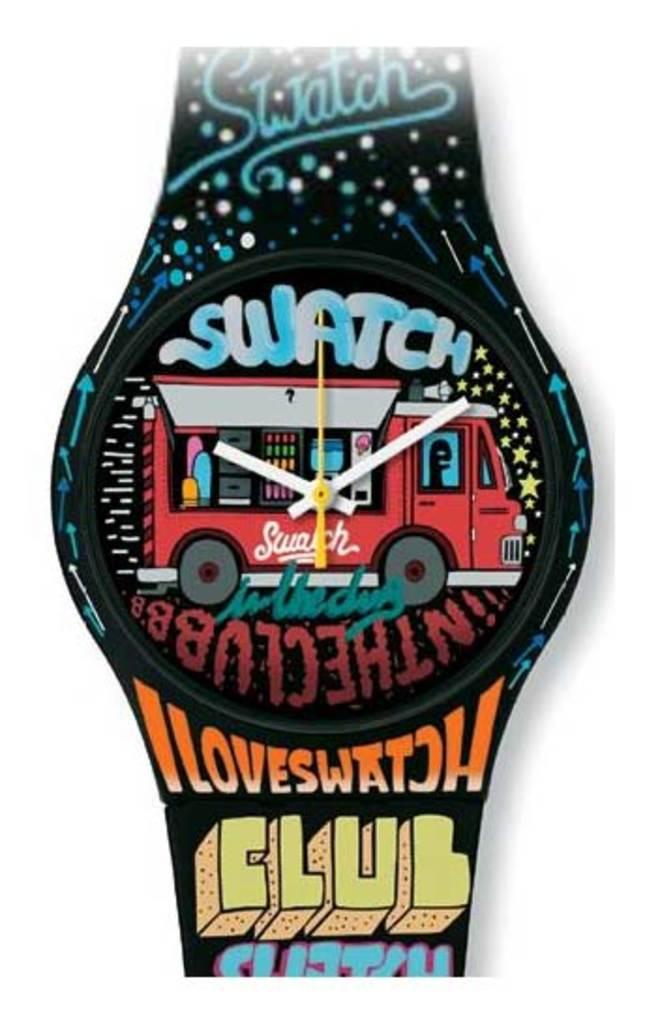What brand of watch is this?
Provide a short and direct response. Swatch. What time is it?
Your answer should be very brief. 10:10. 